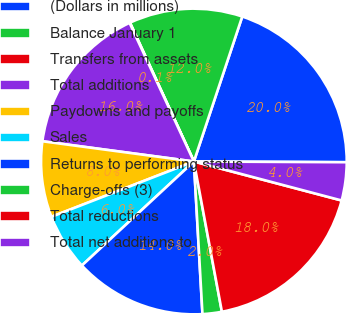<chart> <loc_0><loc_0><loc_500><loc_500><pie_chart><fcel>(Dollars in millions)<fcel>Balance January 1<fcel>Transfers from assets<fcel>Total additions<fcel>Paydowns and payoffs<fcel>Sales<fcel>Returns to performing status<fcel>Charge-offs (3)<fcel>Total reductions<fcel>Total net additions to<nl><fcel>19.95%<fcel>11.99%<fcel>0.05%<fcel>15.97%<fcel>8.01%<fcel>6.02%<fcel>13.98%<fcel>2.04%<fcel>17.96%<fcel>4.03%<nl></chart> 